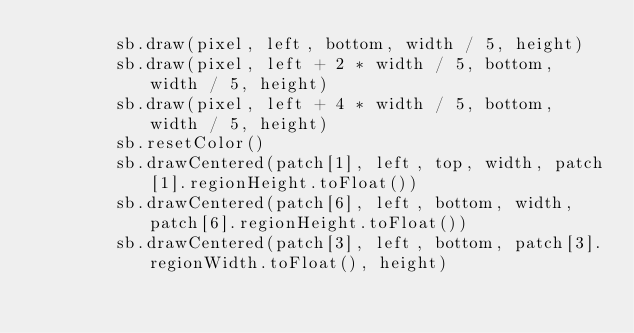Convert code to text. <code><loc_0><loc_0><loc_500><loc_500><_Kotlin_>        sb.draw(pixel, left, bottom, width / 5, height)
        sb.draw(pixel, left + 2 * width / 5, bottom, width / 5, height)
        sb.draw(pixel, left + 4 * width / 5, bottom, width / 5, height)
        sb.resetColor()
        sb.drawCentered(patch[1], left, top, width, patch[1].regionHeight.toFloat())
        sb.drawCentered(patch[6], left, bottom, width, patch[6].regionHeight.toFloat())
        sb.drawCentered(patch[3], left, bottom, patch[3].regionWidth.toFloat(), height)</code> 